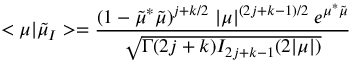<formula> <loc_0><loc_0><loc_500><loc_500>< \mu | \tilde { \mu } _ { I } > = \frac { ( 1 - \tilde { \mu } ^ { * } \tilde { \mu } ) ^ { j + k / 2 } \, | \mu | ^ { ( 2 j + k - 1 ) / 2 } \, e ^ { \mu ^ { * } \tilde { \mu } } } { \sqrt { \Gamma ( 2 j + k ) I _ { 2 j + k - 1 } ( 2 | \mu | ) } }</formula> 